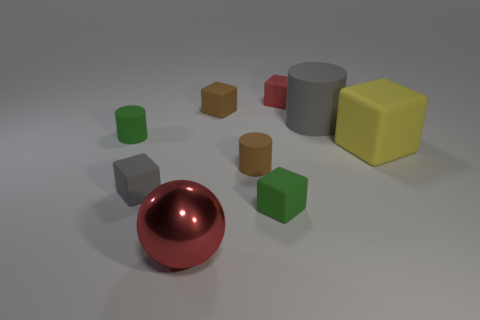How many other things are there of the same material as the brown cube?
Give a very brief answer. 7. Are there the same number of gray matte cylinders that are on the left side of the brown matte block and large gray rubber balls?
Offer a very short reply. Yes. Does the brown matte block have the same size as the red object behind the big gray thing?
Provide a short and direct response. Yes. What shape is the small matte object right of the green cube?
Give a very brief answer. Cube. Is there anything else that is the same shape as the large red metallic object?
Your response must be concise. No. Are there any large gray rubber cylinders?
Ensure brevity in your answer.  Yes. Is the size of the green rubber thing that is on the right side of the small gray matte cube the same as the brown matte object behind the big yellow matte object?
Give a very brief answer. Yes. What is the big thing that is in front of the large gray matte cylinder and to the left of the big block made of?
Make the answer very short. Metal. There is a tiny green rubber cylinder; what number of tiny rubber cylinders are on the right side of it?
Your answer should be very brief. 1. There is a large cylinder that is made of the same material as the red cube; what color is it?
Your response must be concise. Gray. 